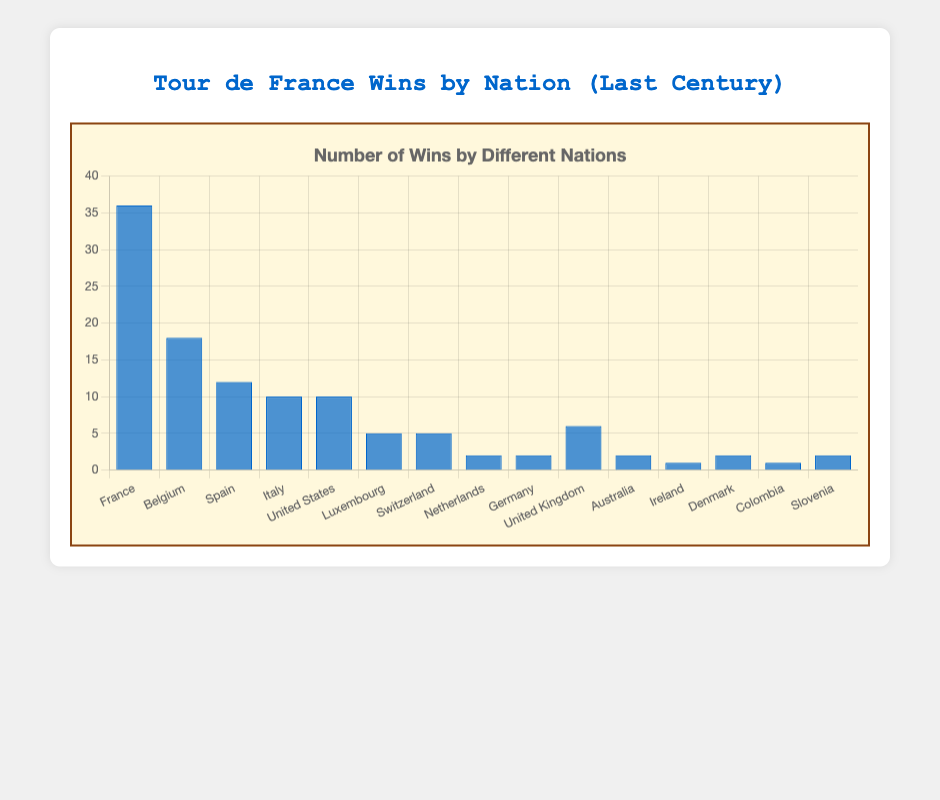Which nation has the highest number of Tour de France wins? The highest bar in the chart represents France, indicating they have the most wins.
Answer: France How many more wins does France have compared to Belgium? France has 36 wins, and Belgium has 18 wins. The difference is 36 - 18.
Answer: 18 Which nations have achieved around a similar number of wins, close to 10? Italy and the United States both have 10 wins, as indicated by their bars reaching the same height.
Answer: Italy, United States What is the combined number of wins for nations with less than 5 wins each? The nations with less than 5 wins are Netherlands (2), Germany (2), Australia (2), Ireland (1), Colombia (1), Denmark (2), and Slovenia (2). The sum is 2 + 2 + 2 + 1 + 1 + 2 + 2 = 12.
Answer: 12 Are there any nations with exactly 5 Tour de France wins? Looking at the chart, the bars for Luxembourg and Switzerland reach the same height at 5 wins.
Answer: Luxembourg, Switzerland Which nation has the highest number of wins in the chart? By comparing the heights of the bars, France's bar is the tallest, showing they have the highest number of wins.
Answer: France What is the sum of wins for France, Belgium, and Spain? Adding the values from the chart, France has 36 wins, Belgium has 18 wins, and Spain has 12 wins. The total is 36 + 18 + 12 = 66.
Answer: 66 Which nations have exactly 2 wins in the Tour de France? Observing the chart, the bars for Netherlands, Germany, Australia, Denmark, and Slovenia all reach the level 2.
Answer: Netherlands, Germany, Australia, Denmark, Slovenia How many nations have more wins than the United Kingdom? Compare the bars’ heights with the United Kingdom's bar (6 wins). Nations with more wins are France (36), Belgium (18), Spain (12), and Italy (10), totaling 4 nations.
Answer: 4 What is the average number of wins for all the listed nations? Adding all the wins and dividing by the number of nations: (36+18+12+10+10+5+5+2+2+6+2+1+2+1+2) = 114; dividing by 15 nations gives 114 / 15 = 7.6.
Answer: 7.6 What is the difference in wins between Spain and the smallest winning nation? Spain has 12 wins, and the smallest winning nations (Ireland and Colombia) each have 1 win. The difference is 12 - 1 = 11.
Answer: 11 